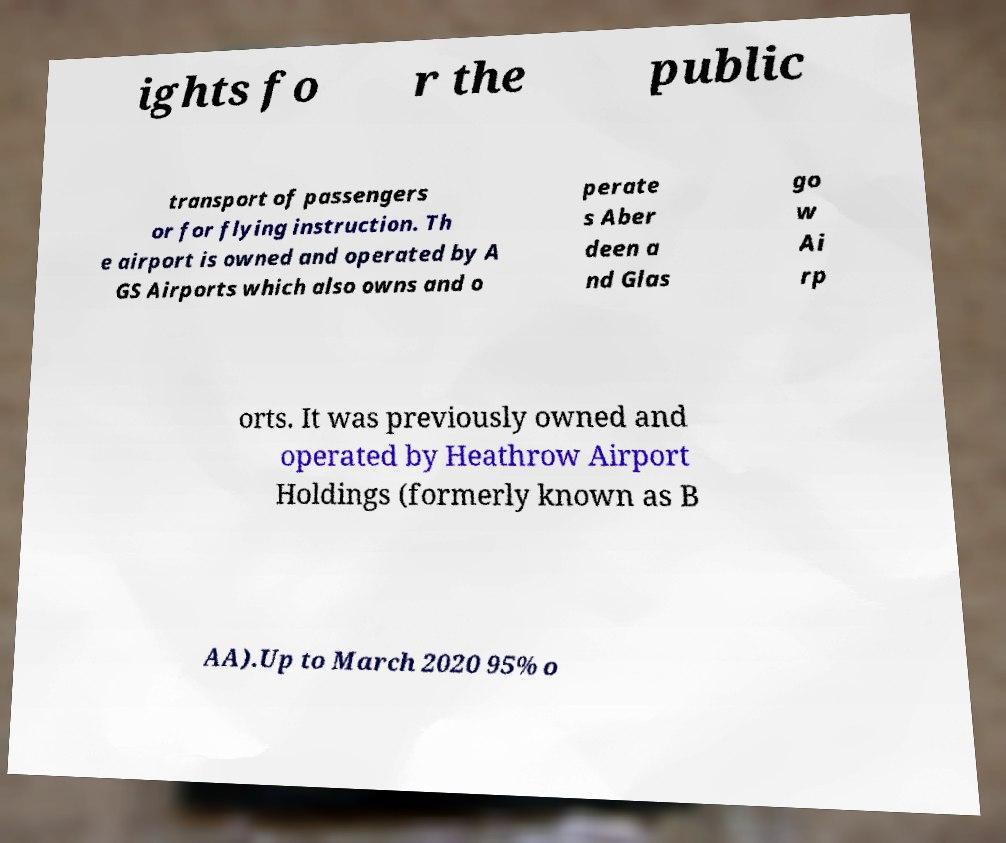Please identify and transcribe the text found in this image. ights fo r the public transport of passengers or for flying instruction. Th e airport is owned and operated by A GS Airports which also owns and o perate s Aber deen a nd Glas go w Ai rp orts. It was previously owned and operated by Heathrow Airport Holdings (formerly known as B AA).Up to March 2020 95% o 